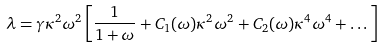Convert formula to latex. <formula><loc_0><loc_0><loc_500><loc_500>\lambda = \gamma \kappa ^ { 2 } \omega ^ { 2 } \left [ \frac { 1 } { 1 + \omega } + C _ { 1 } ( \omega ) \kappa ^ { 2 } \omega ^ { 2 } + C _ { 2 } ( \omega ) \kappa ^ { 4 } \omega ^ { 4 } + \dots \right ]</formula> 